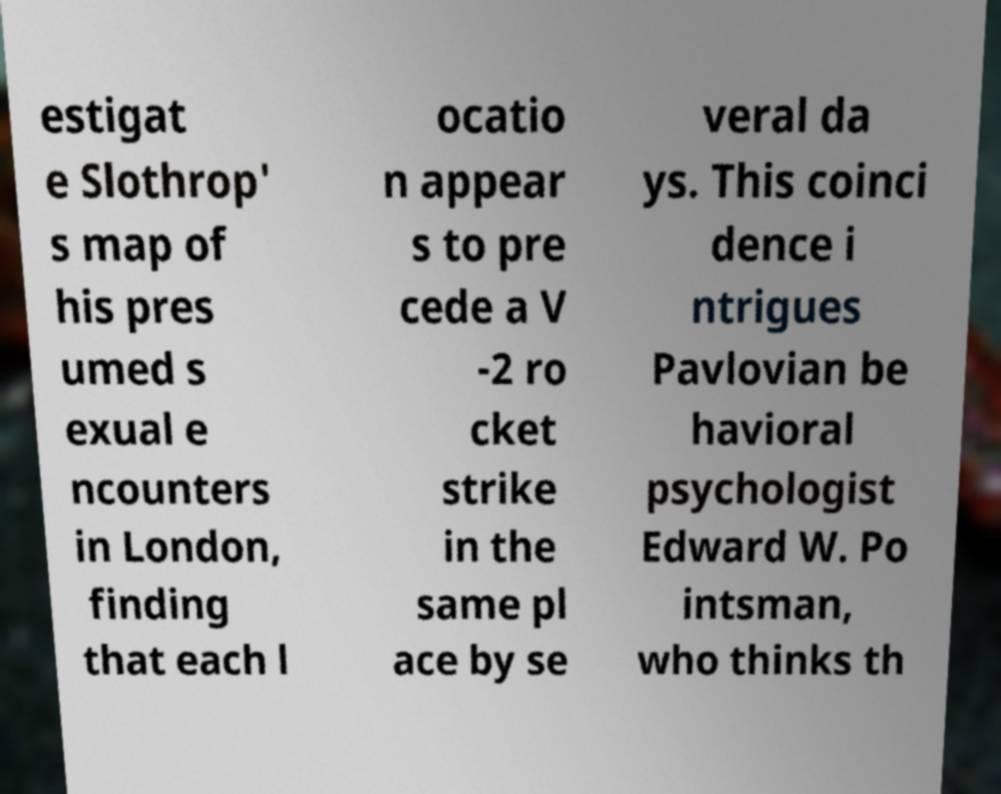Please read and relay the text visible in this image. What does it say? estigat e Slothrop' s map of his pres umed s exual e ncounters in London, finding that each l ocatio n appear s to pre cede a V -2 ro cket strike in the same pl ace by se veral da ys. This coinci dence i ntrigues Pavlovian be havioral psychologist Edward W. Po intsman, who thinks th 